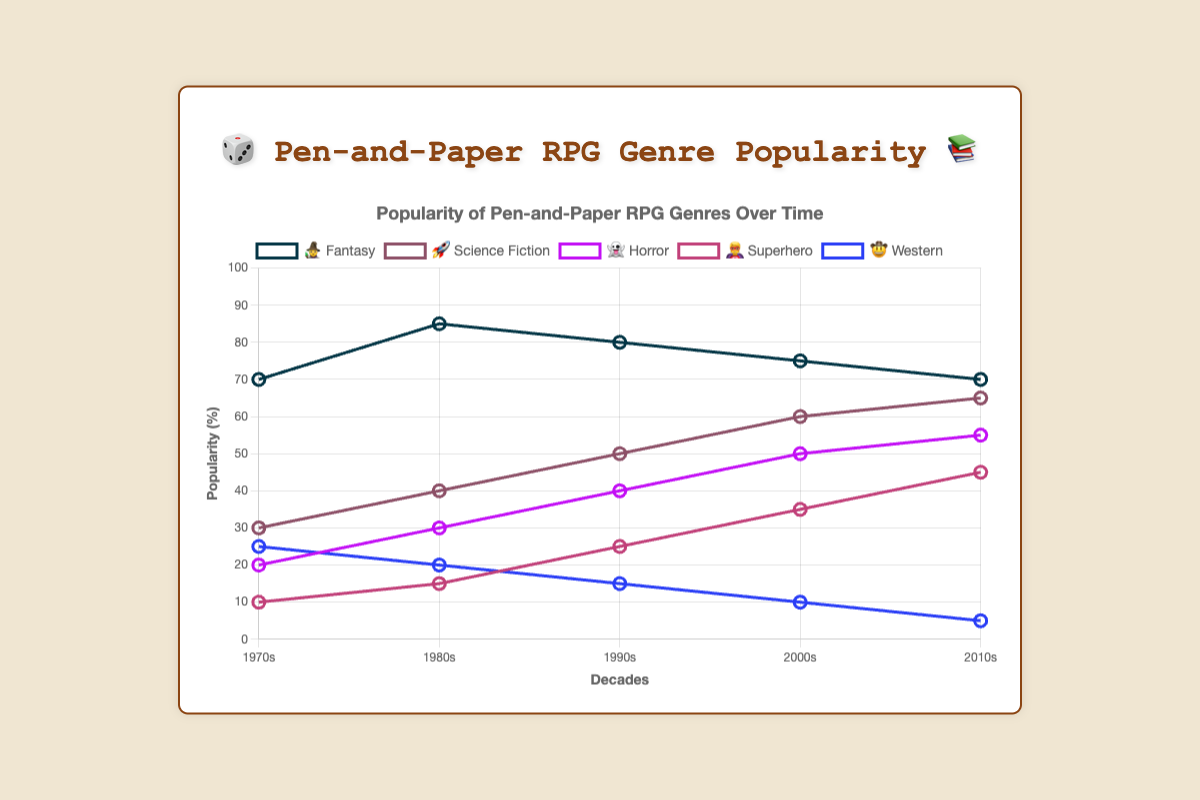Which genre is represented by the emoji 🧙? The legend at the top of the chart shows that the 🧙 emoji corresponds to the Fantasy genre.
Answer: Fantasy During which decade did Science Fiction 🚀 experience the most significant increase in popularity? Looking at the points on the graph for Science Fiction 🚀, the most significant increase occurred from the 1990s to the 2000s, where the popularity rose from 50 to 60.
Answer: 1990s to 2000s What was the popularity percentage of the Horror 👻 genre in the 1990s? The chart shows that the Horror 👻 genre had a popularity of 40% in the 1990s.
Answer: 40% Which genre saw a decline in popularity every decade? The Western 🤠 genre saw a consistent decline, as evidenced by its decreasing percentages from 25% in the 1970s to 5% in the 2010s.
Answer: Western Compare the popularity of Superhero 🦸 in the 1980s to the popularity of Horror 👻 in the 1980s. Which one was more popular and by how much? In the 1980s, Superhero 🦸 had a popularity of 15%, whereas Horror 👻 had 30%. Therefore, Horror 👻 was more popular by 15%.
Answer: Horror, by 15% What is the trend for Fantasy 🧙 from the 1970s to the 2010s? Did its popularity increase, decrease, or remain stable? The Fantasy 🧙 genre's popularity peaked in the 1980s at 85% and then decreased steadily to 70% in the 2010s, indicating a decreasing trend.
Answer: Decrease Which decade shows the highest overall popularity for all genres combined? Summing up the popularity values for each decade: 1970s: 155, 1980s: 190, 1990s: 210, 2000s: 230, 2010s: 240. The 2010s have the highest combined popularity at 240.
Answer: 2010s In which decade did the genre Western 🤠 drop below 10% popularity? The chart shows that the Western 🤠 genre dropped to 10% in the 2000s and then to 5% in the 2010s, so it dropped below 10% in the 2010s.
Answer: 2010s Is there any genre that maintained exactly the same popularity in two different decades? If so, which one? Carefully looking at the trend lines, Fantasy 🧙 maintained exactly the same popularity of 70% in the 1970s and the 2010s.
Answer: Fantasy Which genre experienced the smallest popularity change from the 1970s to the 2010s? By calculating the absolute difference, Science Fiction 🚀 changed from 30% to 65% (+35), Horror 👻 changed from 20% to 55% (+35), Superhero 🦸 changed from 10% to 45% (+35), Western 🤠 changed from 25% to 5% (-20), and Fantasy 🧙 changed from 70% to 70% (0). The smallest change is for Fantasy 🧙.
Answer: Fantasy 